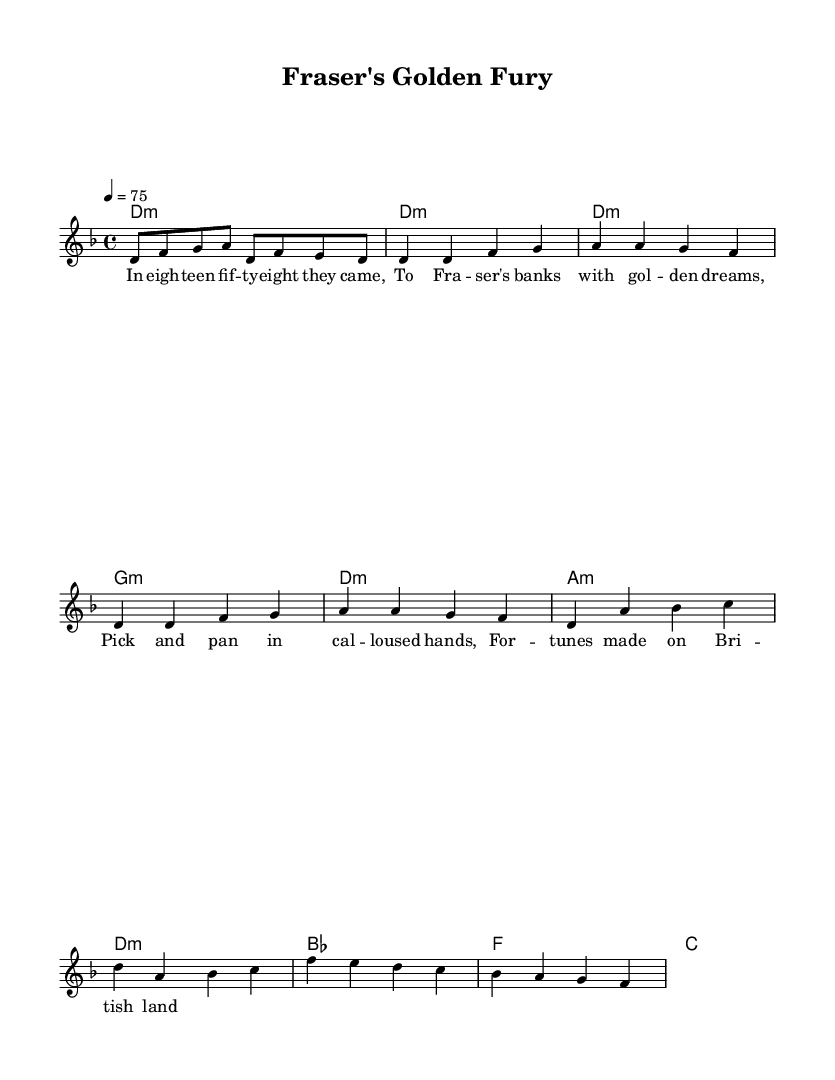What is the key signature of this music? The key signature has two flats (B♭ and E♭), indicating that it is in D minor. The symbol for D minor typically appears at the beginning of the staff.
Answer: D minor What is the time signature of this piece? The time signature is found directly after the key signature and is written as 4/4, meaning there are four beats per measure.
Answer: 4/4 What is the tempo marking of this music? The tempo marking specifies the speed of the piece as "4 = 75," where the number indicates the number of beats per minute. This appears at the beginning of the score.
Answer: 75 How many measures are in the verse section? By counting the measures under the verse section, there are a total of four measures listed.
Answer: 4 Which chord is used at the beginning of the piece? The chord at the beginning, aligned with the first measure, indicates it is a D minor chord (d1:m), showing the root note and its quality.
Answer: D minor What type of lyrics are present in this music? The lyrics are historical ballad lyrics that reflect the gold rush era, which tells a story of miners arriving with dreams of fortune, consistent with the themes typical in metal music.
Answer: Historical ballad Which section features a change in harmony from minor to major? The Chorus section is where the harmony changes from the dominant minor chords in the verse to the more varied harmony of the chorus. This shows a thoughtful contrast, common in metal compositions.
Answer: Chorus 